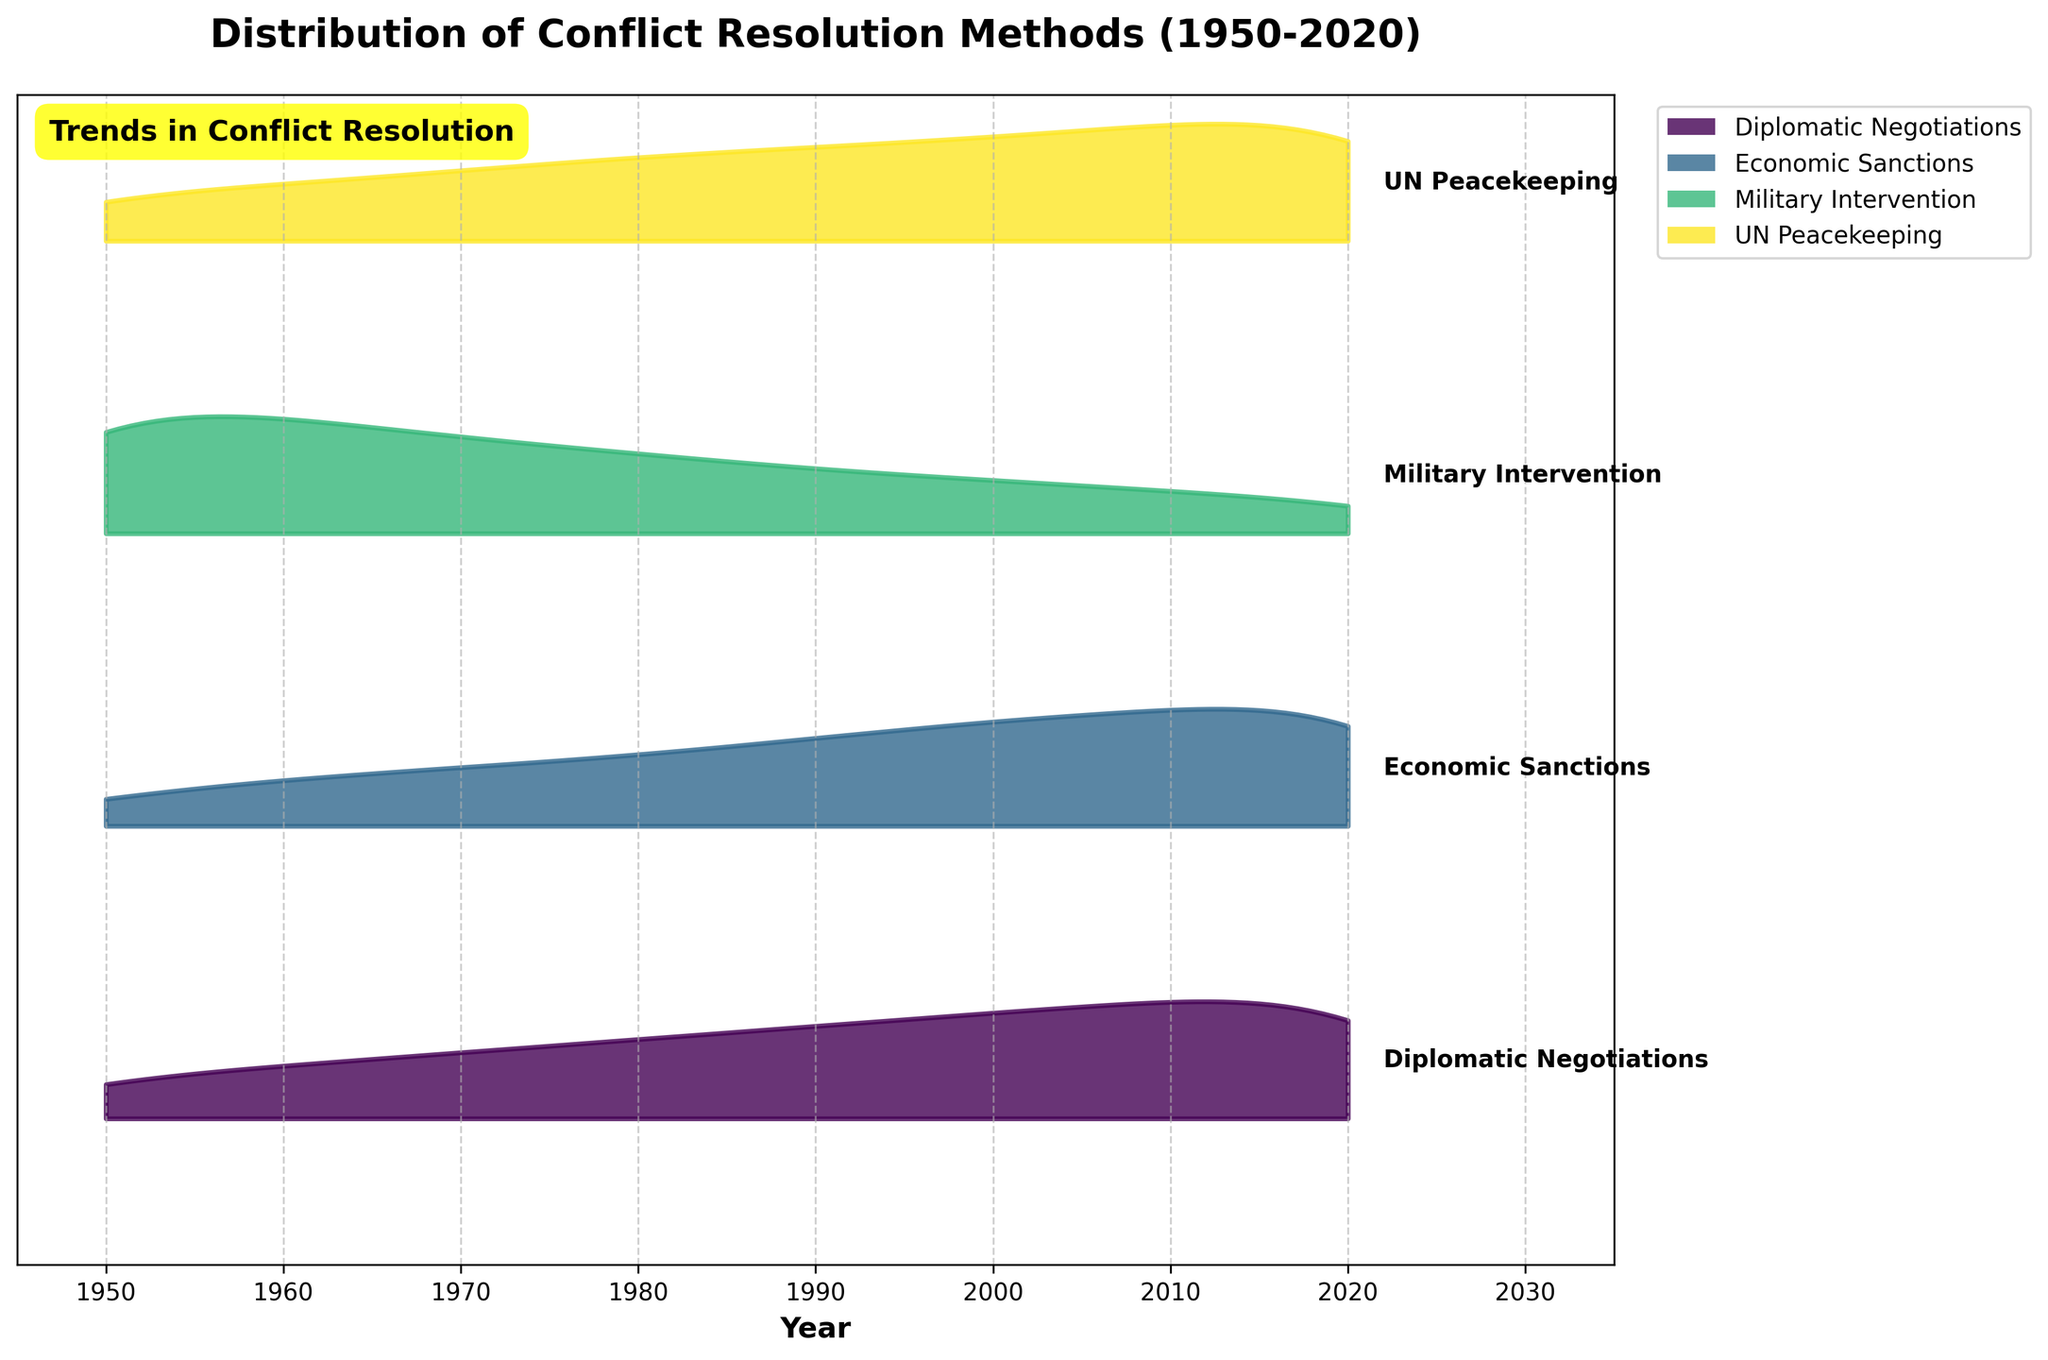What is the title of the ridgeline plot? The title is present at the top of the plot. It reads "Distribution of Conflict Resolution Methods (1950-2020)." Therefore, we can identify the title directly from the plot.
Answer: Distribution of Conflict Resolution Methods (1950-2020) What are the four conflict resolution methods shown in the plot? The methods can be identified by the labels on the right-hand side of the ridgeline plot for each colored ridge. The methods are Diplomatic Negotiations, Economic Sanctions, Military Intervention, and UN Peacekeeping.
Answer: Diplomatic Negotiations, Economic Sanctions, Military Intervention, UN Peacekeeping Which method has the highest frequency in 2020? By looking at the ridgeline plot for the year 2020, note which ridge peak is highest. The highest peak corresponds to Diplomatic Negotiations in 2020.
Answer: Diplomatic Negotiations How has the frequency of Military Intervention changed from 1950 to 2020? We can trace the height of the ridge for Military Intervention from 1950 to 2020. It starts at a higher point in 1950 and gradually declines through the years to reach the lowest point in 2020.
Answer: Decreased What trend can you observe for UN Peacekeeping from 1950 to 2020? By examining the ridge for UN Peacekeeping from 1950 to 2020, it shows a steady increase in frequency, indicating that it has become a more common method over time.
Answer: Increasing Between Economic Sanctions and UN Peacekeeping, which method saw a higher frequency in 1980? The ridgelines for Economic Sanctions and UN Peacekeeping can be compared directly in 1980. The peak of the UN Peacekeeping ridge is higher than the peak of the Economic Sanctions ridge for that year.
Answer: UN Peacekeeping What is the general trend in the use of Diplomatic Negotiations over the entire period from 1950 to 2020? The height of the ridge for Diplomatic Negotiations consistently increases from 1950 to 2020, indicating a growing frequency.
Answer: Increasing Which conflict resolution method was most frequently used in the year 2000? Looking at the ridgeline plot for the year 2000, Diplomatic Negotiations has the highest peak, indicating it was the most frequently used method.
Answer: Diplomatic Negotiations Compare the frequency changes of Economic Sanctions and Military Intervention from 1950 to 2020. The frequency of Economic Sanctions steadily increased from 1950 to 2020, as evidenced by the rising ridge. Conversely, Military Intervention decreased over the same period, as its ridge height declined.
Answer: Economic Sanctions increased; Military Intervention decreased How does the frequency of use for Diplomatic Negotiations in 1960 compare to Military Intervention in 1980? The ridgeline plot shows higher frequency for Diplomatic Negotiations in 1960 compared to the lower frequency for Military Intervention in 1980, as seen from the respective ridge heights.
Answer: Diplomatic Negotiations in 1960 higher 